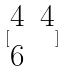Convert formula to latex. <formula><loc_0><loc_0><loc_500><loc_500>[ \begin{matrix} 4 & 4 \\ 6 \end{matrix} ]</formula> 